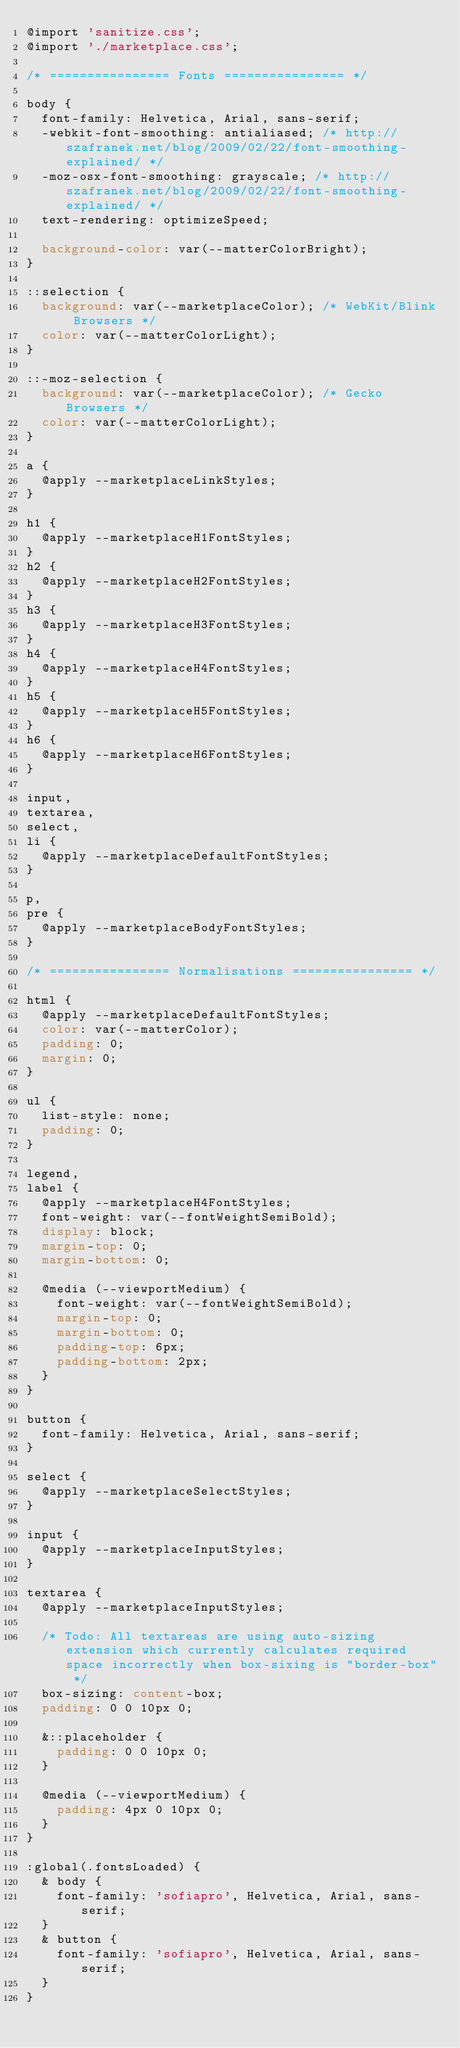<code> <loc_0><loc_0><loc_500><loc_500><_CSS_>@import 'sanitize.css';
@import './marketplace.css';

/* ================ Fonts ================ */

body {
  font-family: Helvetica, Arial, sans-serif;
  -webkit-font-smoothing: antialiased; /* http://szafranek.net/blog/2009/02/22/font-smoothing-explained/ */
  -moz-osx-font-smoothing: grayscale; /* http://szafranek.net/blog/2009/02/22/font-smoothing-explained/ */
  text-rendering: optimizeSpeed;

  background-color: var(--matterColorBright);
}

::selection {
  background: var(--marketplaceColor); /* WebKit/Blink Browsers */
  color: var(--matterColorLight);
}

::-moz-selection {
  background: var(--marketplaceColor); /* Gecko Browsers */
  color: var(--matterColorLight);
}

a {
  @apply --marketplaceLinkStyles;
}

h1 {
  @apply --marketplaceH1FontStyles;
}
h2 {
  @apply --marketplaceH2FontStyles;
}
h3 {
  @apply --marketplaceH3FontStyles;
}
h4 {
  @apply --marketplaceH4FontStyles;
}
h5 {
  @apply --marketplaceH5FontStyles;
}
h6 {
  @apply --marketplaceH6FontStyles;
}

input,
textarea,
select,
li {
  @apply --marketplaceDefaultFontStyles;
}

p,
pre {
  @apply --marketplaceBodyFontStyles;
}

/* ================ Normalisations ================ */

html {
  @apply --marketplaceDefaultFontStyles;
  color: var(--matterColor);
  padding: 0;
  margin: 0;
}

ul {
  list-style: none;
  padding: 0;
}

legend,
label {
  @apply --marketplaceH4FontStyles;
  font-weight: var(--fontWeightSemiBold);
  display: block;
  margin-top: 0;
  margin-bottom: 0;

  @media (--viewportMedium) {
    font-weight: var(--fontWeightSemiBold);
    margin-top: 0;
    margin-bottom: 0;
    padding-top: 6px;
    padding-bottom: 2px;
  }
}

button {
  font-family: Helvetica, Arial, sans-serif;
}

select {
  @apply --marketplaceSelectStyles;
}

input {
  @apply --marketplaceInputStyles;
}

textarea {
  @apply --marketplaceInputStyles;

  /* Todo: All textareas are using auto-sizing extension which currently calculates required space incorrectly when box-sixing is "border-box" */
  box-sizing: content-box;
  padding: 0 0 10px 0;

  &::placeholder {
    padding: 0 0 10px 0;
  }

  @media (--viewportMedium) {
    padding: 4px 0 10px 0;
  }
}

:global(.fontsLoaded) {
  & body {
    font-family: 'sofiapro', Helvetica, Arial, sans-serif;
  }
  & button {
    font-family: 'sofiapro', Helvetica, Arial, sans-serif;
  }
}


</code> 